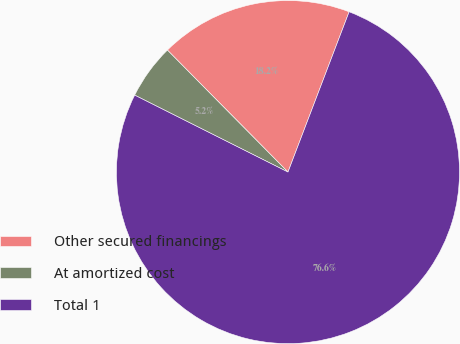<chart> <loc_0><loc_0><loc_500><loc_500><pie_chart><fcel>Other secured financings<fcel>At amortized cost<fcel>Total 1<nl><fcel>18.21%<fcel>5.19%<fcel>76.61%<nl></chart> 